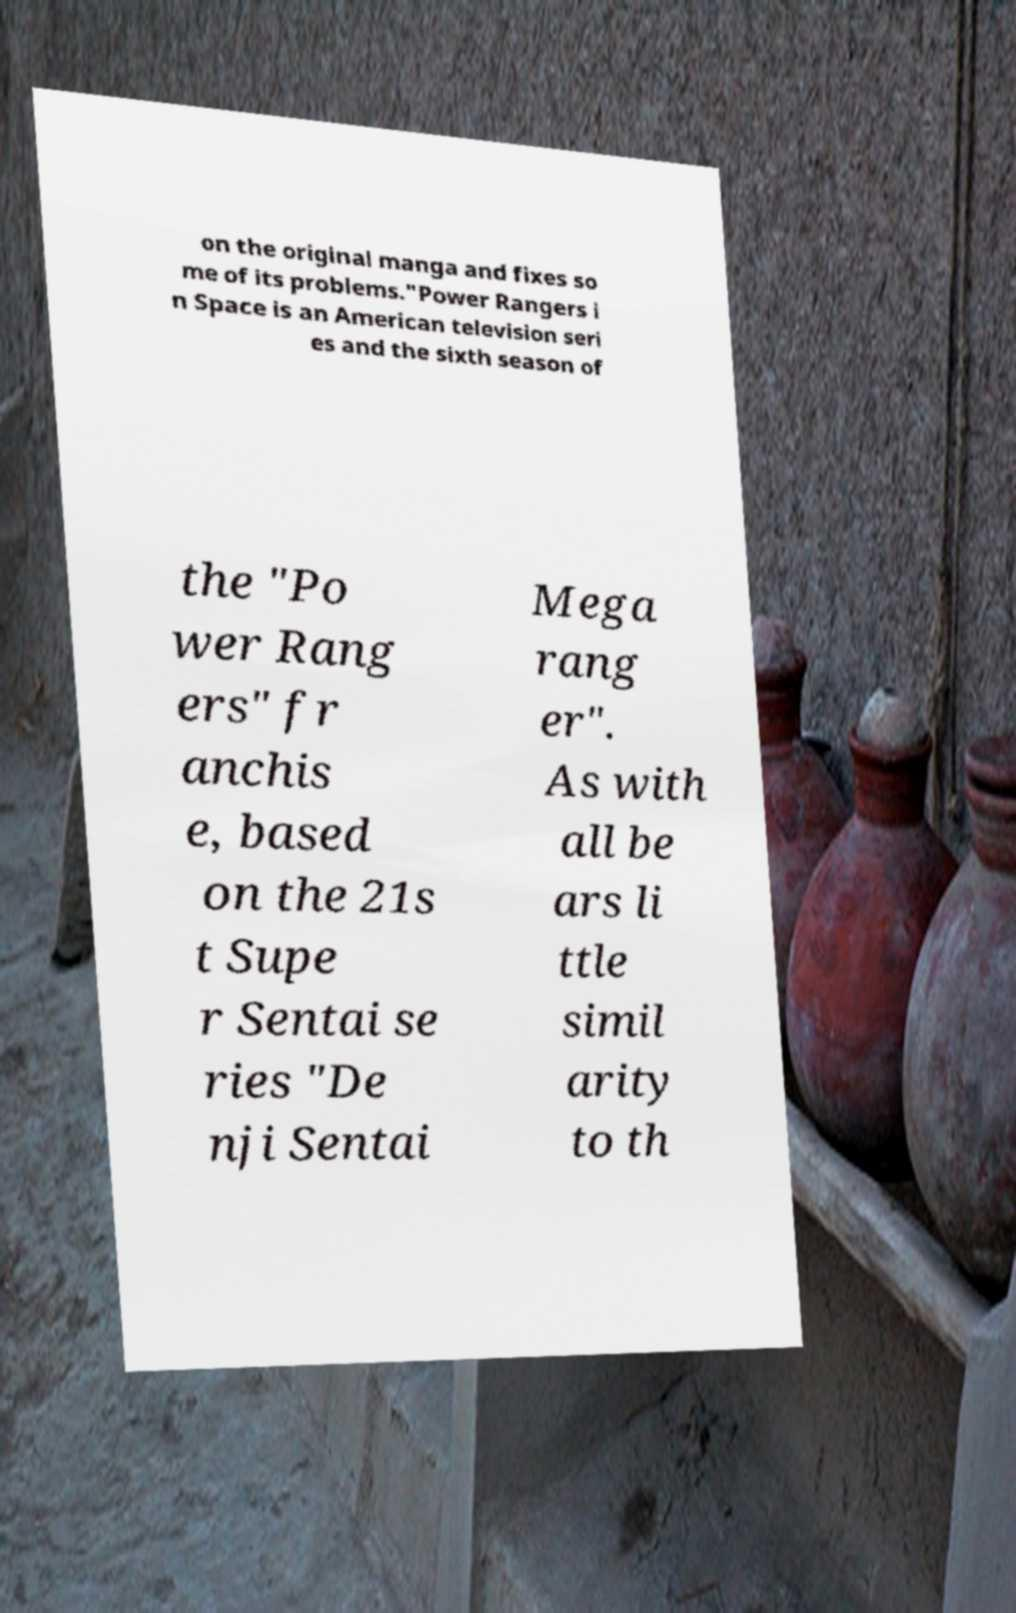Please identify and transcribe the text found in this image. on the original manga and fixes so me of its problems."Power Rangers i n Space is an American television seri es and the sixth season of the "Po wer Rang ers" fr anchis e, based on the 21s t Supe r Sentai se ries "De nji Sentai Mega rang er". As with all be ars li ttle simil arity to th 